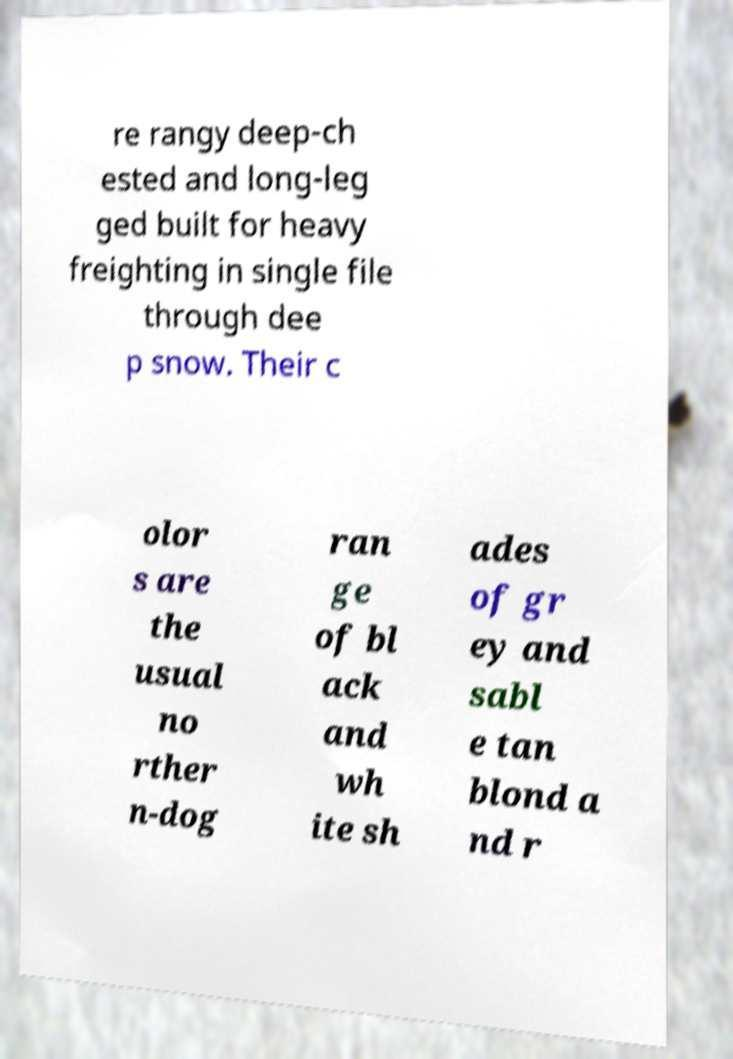I need the written content from this picture converted into text. Can you do that? re rangy deep-ch ested and long-leg ged built for heavy freighting in single file through dee p snow. Their c olor s are the usual no rther n-dog ran ge of bl ack and wh ite sh ades of gr ey and sabl e tan blond a nd r 